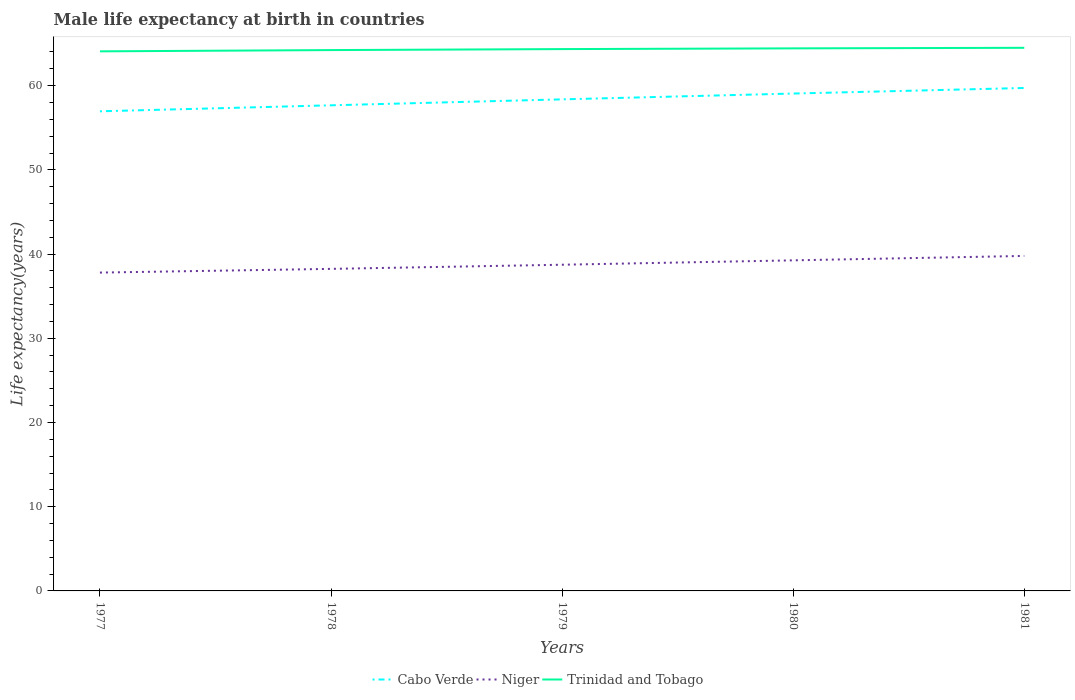Is the number of lines equal to the number of legend labels?
Provide a succinct answer. Yes. Across all years, what is the maximum male life expectancy at birth in Trinidad and Tobago?
Make the answer very short. 64.08. What is the total male life expectancy at birth in Niger in the graph?
Provide a short and direct response. -1.05. What is the difference between the highest and the second highest male life expectancy at birth in Cabo Verde?
Provide a short and direct response. 2.77. What is the difference between the highest and the lowest male life expectancy at birth in Trinidad and Tobago?
Provide a short and direct response. 3. How many lines are there?
Offer a terse response. 3. What is the difference between two consecutive major ticks on the Y-axis?
Offer a terse response. 10. Does the graph contain any zero values?
Ensure brevity in your answer.  No. Where does the legend appear in the graph?
Ensure brevity in your answer.  Bottom center. How are the legend labels stacked?
Keep it short and to the point. Horizontal. What is the title of the graph?
Your answer should be compact. Male life expectancy at birth in countries. Does "Zambia" appear as one of the legend labels in the graph?
Your answer should be very brief. No. What is the label or title of the Y-axis?
Keep it short and to the point. Life expectancy(years). What is the Life expectancy(years) in Cabo Verde in 1977?
Offer a very short reply. 56.96. What is the Life expectancy(years) of Niger in 1977?
Keep it short and to the point. 37.8. What is the Life expectancy(years) of Trinidad and Tobago in 1977?
Ensure brevity in your answer.  64.08. What is the Life expectancy(years) of Cabo Verde in 1978?
Offer a very short reply. 57.67. What is the Life expectancy(years) of Niger in 1978?
Make the answer very short. 38.24. What is the Life expectancy(years) in Trinidad and Tobago in 1978?
Make the answer very short. 64.23. What is the Life expectancy(years) in Cabo Verde in 1979?
Provide a succinct answer. 58.37. What is the Life expectancy(years) in Niger in 1979?
Your response must be concise. 38.74. What is the Life expectancy(years) in Trinidad and Tobago in 1979?
Ensure brevity in your answer.  64.34. What is the Life expectancy(years) in Cabo Verde in 1980?
Offer a terse response. 59.06. What is the Life expectancy(years) in Niger in 1980?
Give a very brief answer. 39.26. What is the Life expectancy(years) of Trinidad and Tobago in 1980?
Make the answer very short. 64.43. What is the Life expectancy(years) of Cabo Verde in 1981?
Your response must be concise. 59.73. What is the Life expectancy(years) of Niger in 1981?
Keep it short and to the point. 39.78. What is the Life expectancy(years) in Trinidad and Tobago in 1981?
Keep it short and to the point. 64.5. Across all years, what is the maximum Life expectancy(years) in Cabo Verde?
Offer a very short reply. 59.73. Across all years, what is the maximum Life expectancy(years) of Niger?
Provide a succinct answer. 39.78. Across all years, what is the maximum Life expectancy(years) in Trinidad and Tobago?
Your answer should be compact. 64.5. Across all years, what is the minimum Life expectancy(years) of Cabo Verde?
Ensure brevity in your answer.  56.96. Across all years, what is the minimum Life expectancy(years) in Niger?
Provide a succinct answer. 37.8. Across all years, what is the minimum Life expectancy(years) in Trinidad and Tobago?
Provide a succinct answer. 64.08. What is the total Life expectancy(years) of Cabo Verde in the graph?
Provide a short and direct response. 291.79. What is the total Life expectancy(years) of Niger in the graph?
Offer a very short reply. 193.82. What is the total Life expectancy(years) in Trinidad and Tobago in the graph?
Keep it short and to the point. 321.57. What is the difference between the Life expectancy(years) in Cabo Verde in 1977 and that in 1978?
Your answer should be very brief. -0.71. What is the difference between the Life expectancy(years) in Niger in 1977 and that in 1978?
Your response must be concise. -0.44. What is the difference between the Life expectancy(years) in Trinidad and Tobago in 1977 and that in 1978?
Provide a short and direct response. -0.15. What is the difference between the Life expectancy(years) in Cabo Verde in 1977 and that in 1979?
Your response must be concise. -1.42. What is the difference between the Life expectancy(years) of Niger in 1977 and that in 1979?
Provide a succinct answer. -0.93. What is the difference between the Life expectancy(years) in Trinidad and Tobago in 1977 and that in 1979?
Make the answer very short. -0.27. What is the difference between the Life expectancy(years) in Cabo Verde in 1977 and that in 1980?
Your response must be concise. -2.11. What is the difference between the Life expectancy(years) of Niger in 1977 and that in 1980?
Offer a terse response. -1.45. What is the difference between the Life expectancy(years) of Trinidad and Tobago in 1977 and that in 1980?
Give a very brief answer. -0.35. What is the difference between the Life expectancy(years) of Cabo Verde in 1977 and that in 1981?
Your answer should be very brief. -2.77. What is the difference between the Life expectancy(years) of Niger in 1977 and that in 1981?
Your answer should be compact. -1.98. What is the difference between the Life expectancy(years) in Trinidad and Tobago in 1977 and that in 1981?
Your response must be concise. -0.42. What is the difference between the Life expectancy(years) in Cabo Verde in 1978 and that in 1979?
Give a very brief answer. -0.71. What is the difference between the Life expectancy(years) in Niger in 1978 and that in 1979?
Your answer should be compact. -0.49. What is the difference between the Life expectancy(years) in Trinidad and Tobago in 1978 and that in 1979?
Your response must be concise. -0.12. What is the difference between the Life expectancy(years) of Cabo Verde in 1978 and that in 1980?
Give a very brief answer. -1.4. What is the difference between the Life expectancy(years) in Niger in 1978 and that in 1980?
Provide a succinct answer. -1.01. What is the difference between the Life expectancy(years) in Trinidad and Tobago in 1978 and that in 1980?
Keep it short and to the point. -0.2. What is the difference between the Life expectancy(years) in Cabo Verde in 1978 and that in 1981?
Give a very brief answer. -2.06. What is the difference between the Life expectancy(years) of Niger in 1978 and that in 1981?
Your answer should be very brief. -1.54. What is the difference between the Life expectancy(years) in Trinidad and Tobago in 1978 and that in 1981?
Your answer should be very brief. -0.27. What is the difference between the Life expectancy(years) in Cabo Verde in 1979 and that in 1980?
Keep it short and to the point. -0.69. What is the difference between the Life expectancy(years) in Niger in 1979 and that in 1980?
Your answer should be compact. -0.52. What is the difference between the Life expectancy(years) in Trinidad and Tobago in 1979 and that in 1980?
Your answer should be very brief. -0.09. What is the difference between the Life expectancy(years) in Cabo Verde in 1979 and that in 1981?
Give a very brief answer. -1.35. What is the difference between the Life expectancy(years) of Niger in 1979 and that in 1981?
Keep it short and to the point. -1.04. What is the difference between the Life expectancy(years) of Trinidad and Tobago in 1979 and that in 1981?
Your answer should be compact. -0.15. What is the difference between the Life expectancy(years) in Cabo Verde in 1980 and that in 1981?
Your answer should be very brief. -0.66. What is the difference between the Life expectancy(years) in Niger in 1980 and that in 1981?
Provide a short and direct response. -0.52. What is the difference between the Life expectancy(years) in Trinidad and Tobago in 1980 and that in 1981?
Ensure brevity in your answer.  -0.07. What is the difference between the Life expectancy(years) in Cabo Verde in 1977 and the Life expectancy(years) in Niger in 1978?
Your answer should be compact. 18.71. What is the difference between the Life expectancy(years) in Cabo Verde in 1977 and the Life expectancy(years) in Trinidad and Tobago in 1978?
Ensure brevity in your answer.  -7.27. What is the difference between the Life expectancy(years) of Niger in 1977 and the Life expectancy(years) of Trinidad and Tobago in 1978?
Give a very brief answer. -26.42. What is the difference between the Life expectancy(years) in Cabo Verde in 1977 and the Life expectancy(years) in Niger in 1979?
Give a very brief answer. 18.22. What is the difference between the Life expectancy(years) in Cabo Verde in 1977 and the Life expectancy(years) in Trinidad and Tobago in 1979?
Offer a very short reply. -7.39. What is the difference between the Life expectancy(years) of Niger in 1977 and the Life expectancy(years) of Trinidad and Tobago in 1979?
Keep it short and to the point. -26.54. What is the difference between the Life expectancy(years) of Cabo Verde in 1977 and the Life expectancy(years) of Niger in 1980?
Make the answer very short. 17.7. What is the difference between the Life expectancy(years) of Cabo Verde in 1977 and the Life expectancy(years) of Trinidad and Tobago in 1980?
Provide a short and direct response. -7.47. What is the difference between the Life expectancy(years) of Niger in 1977 and the Life expectancy(years) of Trinidad and Tobago in 1980?
Keep it short and to the point. -26.63. What is the difference between the Life expectancy(years) of Cabo Verde in 1977 and the Life expectancy(years) of Niger in 1981?
Provide a short and direct response. 17.18. What is the difference between the Life expectancy(years) in Cabo Verde in 1977 and the Life expectancy(years) in Trinidad and Tobago in 1981?
Offer a very short reply. -7.54. What is the difference between the Life expectancy(years) in Niger in 1977 and the Life expectancy(years) in Trinidad and Tobago in 1981?
Offer a terse response. -26.69. What is the difference between the Life expectancy(years) in Cabo Verde in 1978 and the Life expectancy(years) in Niger in 1979?
Make the answer very short. 18.93. What is the difference between the Life expectancy(years) of Cabo Verde in 1978 and the Life expectancy(years) of Trinidad and Tobago in 1979?
Offer a very short reply. -6.68. What is the difference between the Life expectancy(years) of Niger in 1978 and the Life expectancy(years) of Trinidad and Tobago in 1979?
Your response must be concise. -26.1. What is the difference between the Life expectancy(years) in Cabo Verde in 1978 and the Life expectancy(years) in Niger in 1980?
Offer a terse response. 18.41. What is the difference between the Life expectancy(years) of Cabo Verde in 1978 and the Life expectancy(years) of Trinidad and Tobago in 1980?
Give a very brief answer. -6.76. What is the difference between the Life expectancy(years) in Niger in 1978 and the Life expectancy(years) in Trinidad and Tobago in 1980?
Provide a short and direct response. -26.19. What is the difference between the Life expectancy(years) of Cabo Verde in 1978 and the Life expectancy(years) of Niger in 1981?
Your answer should be very brief. 17.89. What is the difference between the Life expectancy(years) of Cabo Verde in 1978 and the Life expectancy(years) of Trinidad and Tobago in 1981?
Offer a very short reply. -6.83. What is the difference between the Life expectancy(years) in Niger in 1978 and the Life expectancy(years) in Trinidad and Tobago in 1981?
Your answer should be very brief. -26.25. What is the difference between the Life expectancy(years) of Cabo Verde in 1979 and the Life expectancy(years) of Niger in 1980?
Provide a succinct answer. 19.12. What is the difference between the Life expectancy(years) in Cabo Verde in 1979 and the Life expectancy(years) in Trinidad and Tobago in 1980?
Offer a very short reply. -6.06. What is the difference between the Life expectancy(years) in Niger in 1979 and the Life expectancy(years) in Trinidad and Tobago in 1980?
Provide a succinct answer. -25.69. What is the difference between the Life expectancy(years) of Cabo Verde in 1979 and the Life expectancy(years) of Niger in 1981?
Provide a succinct answer. 18.59. What is the difference between the Life expectancy(years) in Cabo Verde in 1979 and the Life expectancy(years) in Trinidad and Tobago in 1981?
Provide a short and direct response. -6.12. What is the difference between the Life expectancy(years) in Niger in 1979 and the Life expectancy(years) in Trinidad and Tobago in 1981?
Provide a succinct answer. -25.76. What is the difference between the Life expectancy(years) of Cabo Verde in 1980 and the Life expectancy(years) of Niger in 1981?
Your answer should be compact. 19.28. What is the difference between the Life expectancy(years) of Cabo Verde in 1980 and the Life expectancy(years) of Trinidad and Tobago in 1981?
Provide a succinct answer. -5.43. What is the difference between the Life expectancy(years) in Niger in 1980 and the Life expectancy(years) in Trinidad and Tobago in 1981?
Offer a terse response. -25.24. What is the average Life expectancy(years) in Cabo Verde per year?
Offer a very short reply. 58.36. What is the average Life expectancy(years) in Niger per year?
Keep it short and to the point. 38.76. What is the average Life expectancy(years) in Trinidad and Tobago per year?
Make the answer very short. 64.31. In the year 1977, what is the difference between the Life expectancy(years) in Cabo Verde and Life expectancy(years) in Niger?
Provide a short and direct response. 19.15. In the year 1977, what is the difference between the Life expectancy(years) in Cabo Verde and Life expectancy(years) in Trinidad and Tobago?
Your answer should be compact. -7.12. In the year 1977, what is the difference between the Life expectancy(years) of Niger and Life expectancy(years) of Trinidad and Tobago?
Your response must be concise. -26.27. In the year 1978, what is the difference between the Life expectancy(years) of Cabo Verde and Life expectancy(years) of Niger?
Provide a short and direct response. 19.42. In the year 1978, what is the difference between the Life expectancy(years) in Cabo Verde and Life expectancy(years) in Trinidad and Tobago?
Offer a terse response. -6.56. In the year 1978, what is the difference between the Life expectancy(years) in Niger and Life expectancy(years) in Trinidad and Tobago?
Your response must be concise. -25.98. In the year 1979, what is the difference between the Life expectancy(years) in Cabo Verde and Life expectancy(years) in Niger?
Keep it short and to the point. 19.64. In the year 1979, what is the difference between the Life expectancy(years) of Cabo Verde and Life expectancy(years) of Trinidad and Tobago?
Your answer should be very brief. -5.97. In the year 1979, what is the difference between the Life expectancy(years) in Niger and Life expectancy(years) in Trinidad and Tobago?
Offer a very short reply. -25.61. In the year 1980, what is the difference between the Life expectancy(years) in Cabo Verde and Life expectancy(years) in Niger?
Your answer should be compact. 19.81. In the year 1980, what is the difference between the Life expectancy(years) in Cabo Verde and Life expectancy(years) in Trinidad and Tobago?
Make the answer very short. -5.37. In the year 1980, what is the difference between the Life expectancy(years) in Niger and Life expectancy(years) in Trinidad and Tobago?
Provide a short and direct response. -25.17. In the year 1981, what is the difference between the Life expectancy(years) in Cabo Verde and Life expectancy(years) in Niger?
Give a very brief answer. 19.94. In the year 1981, what is the difference between the Life expectancy(years) in Cabo Verde and Life expectancy(years) in Trinidad and Tobago?
Ensure brevity in your answer.  -4.77. In the year 1981, what is the difference between the Life expectancy(years) in Niger and Life expectancy(years) in Trinidad and Tobago?
Provide a short and direct response. -24.71. What is the ratio of the Life expectancy(years) of Cabo Verde in 1977 to that in 1979?
Give a very brief answer. 0.98. What is the ratio of the Life expectancy(years) of Niger in 1977 to that in 1979?
Your response must be concise. 0.98. What is the ratio of the Life expectancy(years) in Trinidad and Tobago in 1977 to that in 1980?
Provide a succinct answer. 0.99. What is the ratio of the Life expectancy(years) of Cabo Verde in 1977 to that in 1981?
Offer a terse response. 0.95. What is the ratio of the Life expectancy(years) in Niger in 1977 to that in 1981?
Make the answer very short. 0.95. What is the ratio of the Life expectancy(years) in Trinidad and Tobago in 1977 to that in 1981?
Make the answer very short. 0.99. What is the ratio of the Life expectancy(years) of Cabo Verde in 1978 to that in 1979?
Ensure brevity in your answer.  0.99. What is the ratio of the Life expectancy(years) in Niger in 1978 to that in 1979?
Ensure brevity in your answer.  0.99. What is the ratio of the Life expectancy(years) of Cabo Verde in 1978 to that in 1980?
Keep it short and to the point. 0.98. What is the ratio of the Life expectancy(years) of Niger in 1978 to that in 1980?
Ensure brevity in your answer.  0.97. What is the ratio of the Life expectancy(years) in Cabo Verde in 1978 to that in 1981?
Your response must be concise. 0.97. What is the ratio of the Life expectancy(years) of Niger in 1978 to that in 1981?
Ensure brevity in your answer.  0.96. What is the ratio of the Life expectancy(years) in Trinidad and Tobago in 1978 to that in 1981?
Your answer should be compact. 1. What is the ratio of the Life expectancy(years) in Cabo Verde in 1979 to that in 1980?
Offer a terse response. 0.99. What is the ratio of the Life expectancy(years) in Niger in 1979 to that in 1980?
Offer a very short reply. 0.99. What is the ratio of the Life expectancy(years) of Trinidad and Tobago in 1979 to that in 1980?
Keep it short and to the point. 1. What is the ratio of the Life expectancy(years) of Cabo Verde in 1979 to that in 1981?
Offer a terse response. 0.98. What is the ratio of the Life expectancy(years) of Niger in 1979 to that in 1981?
Keep it short and to the point. 0.97. What is the ratio of the Life expectancy(years) of Cabo Verde in 1980 to that in 1981?
Offer a very short reply. 0.99. What is the ratio of the Life expectancy(years) in Niger in 1980 to that in 1981?
Provide a succinct answer. 0.99. What is the difference between the highest and the second highest Life expectancy(years) in Cabo Verde?
Offer a terse response. 0.66. What is the difference between the highest and the second highest Life expectancy(years) in Niger?
Your answer should be very brief. 0.52. What is the difference between the highest and the second highest Life expectancy(years) in Trinidad and Tobago?
Offer a very short reply. 0.07. What is the difference between the highest and the lowest Life expectancy(years) of Cabo Verde?
Offer a very short reply. 2.77. What is the difference between the highest and the lowest Life expectancy(years) of Niger?
Keep it short and to the point. 1.98. What is the difference between the highest and the lowest Life expectancy(years) in Trinidad and Tobago?
Ensure brevity in your answer.  0.42. 